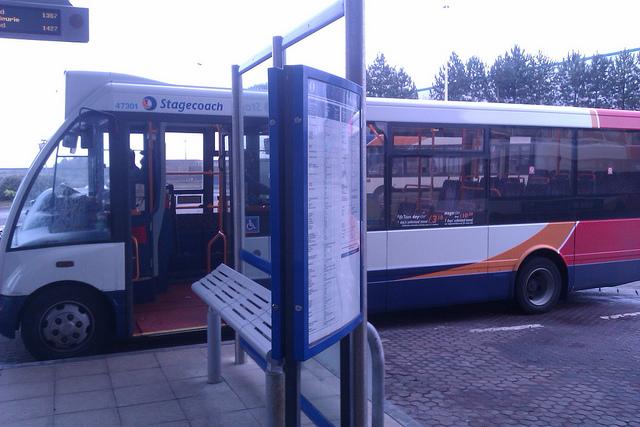Would a person at this location be able to tell when this bus would arrive next?
Short answer required. Yes. Is the bus full?
Keep it brief. No. What type of vehicle is in the photo?
Short answer required. Bus. 